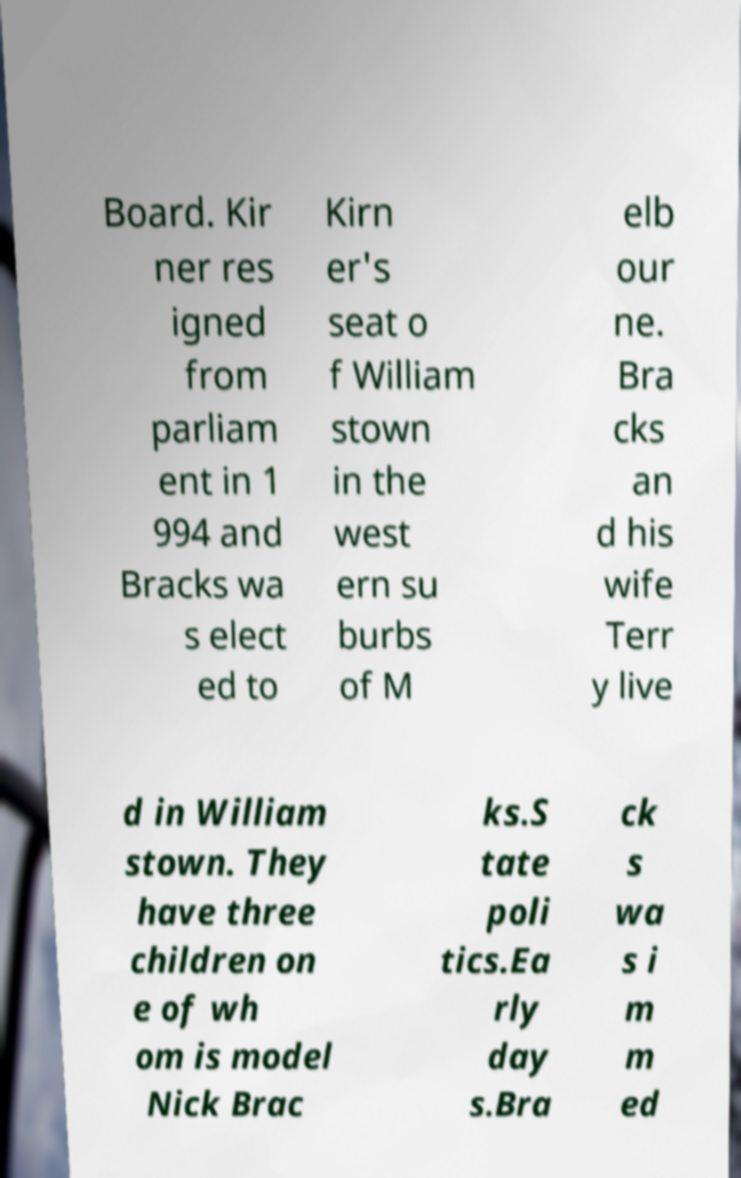Could you assist in decoding the text presented in this image and type it out clearly? Board. Kir ner res igned from parliam ent in 1 994 and Bracks wa s elect ed to Kirn er's seat o f William stown in the west ern su burbs of M elb our ne. Bra cks an d his wife Terr y live d in William stown. They have three children on e of wh om is model Nick Brac ks.S tate poli tics.Ea rly day s.Bra ck s wa s i m m ed 